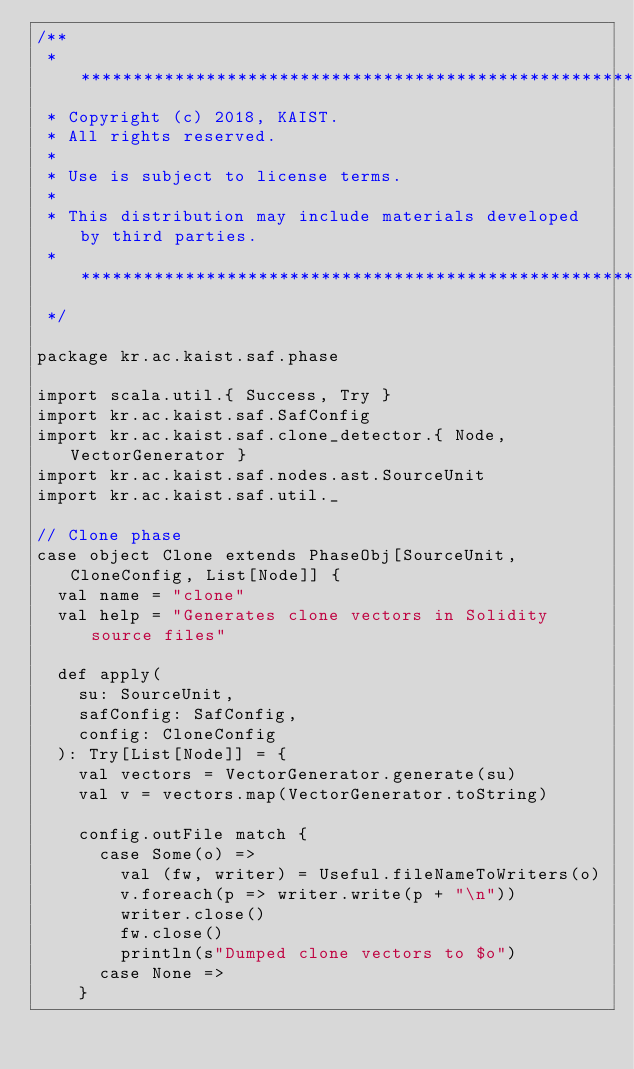Convert code to text. <code><loc_0><loc_0><loc_500><loc_500><_Scala_>/**
 * *****************************************************************************
 * Copyright (c) 2018, KAIST.
 * All rights reserved.
 *
 * Use is subject to license terms.
 *
 * This distribution may include materials developed by third parties.
 * ****************************************************************************
 */

package kr.ac.kaist.saf.phase

import scala.util.{ Success, Try }
import kr.ac.kaist.saf.SafConfig
import kr.ac.kaist.saf.clone_detector.{ Node, VectorGenerator }
import kr.ac.kaist.saf.nodes.ast.SourceUnit
import kr.ac.kaist.saf.util._

// Clone phase
case object Clone extends PhaseObj[SourceUnit, CloneConfig, List[Node]] {
  val name = "clone"
  val help = "Generates clone vectors in Solidity source files"

  def apply(
    su: SourceUnit,
    safConfig: SafConfig,
    config: CloneConfig
  ): Try[List[Node]] = {
    val vectors = VectorGenerator.generate(su)
    val v = vectors.map(VectorGenerator.toString)

    config.outFile match {
      case Some(o) =>
        val (fw, writer) = Useful.fileNameToWriters(o)
        v.foreach(p => writer.write(p + "\n"))
        writer.close()
        fw.close()
        println(s"Dumped clone vectors to $o")
      case None =>
    }
</code> 